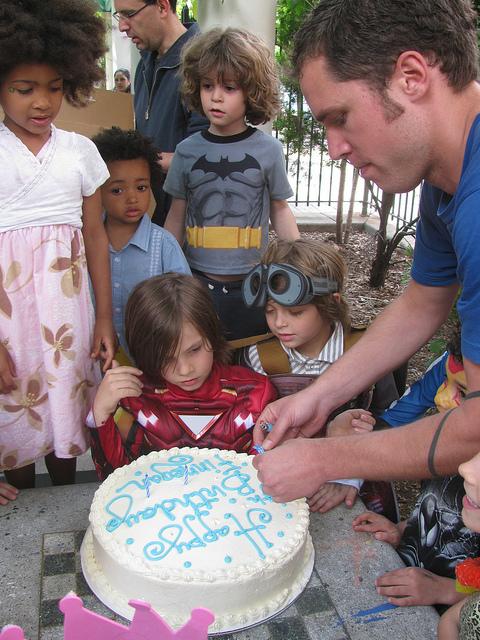What is the man holding?
Quick response, please. Candles. What is the man doing?
Answer briefly. Putting candles on cake. Are the people celebrating?
Concise answer only. Yes. 